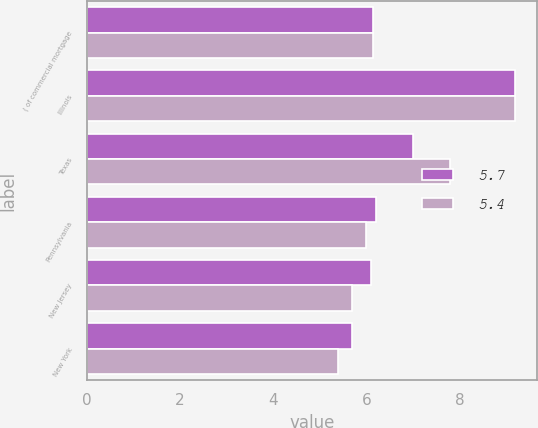Convert chart to OTSL. <chart><loc_0><loc_0><loc_500><loc_500><stacked_bar_chart><ecel><fcel>( of commercial mortgage<fcel>Illinois<fcel>Texas<fcel>Pennsylvania<fcel>New Jersey<fcel>New York<nl><fcel>5.7<fcel>6.15<fcel>9.2<fcel>7<fcel>6.2<fcel>6.1<fcel>5.7<nl><fcel>5.4<fcel>6.15<fcel>9.2<fcel>7.8<fcel>6<fcel>5.7<fcel>5.4<nl></chart> 